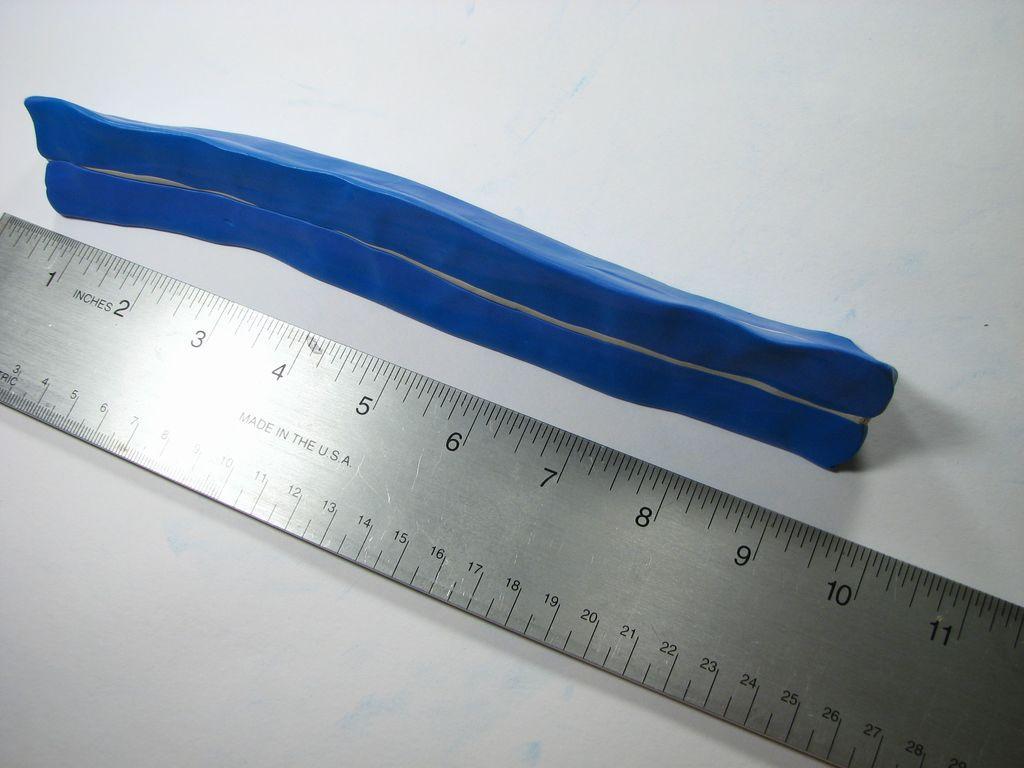Could you give a brief overview of what you see in this image? In the picture I can see a metal scale and a blue color object on a white color surface. 